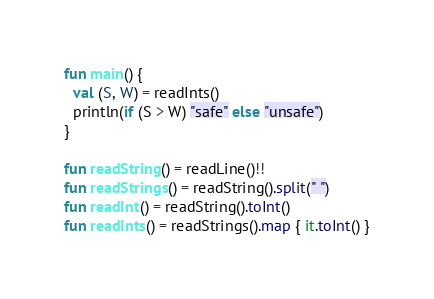<code> <loc_0><loc_0><loc_500><loc_500><_Kotlin_>fun main() {
  val (S, W) = readInts()
  println(if (S > W) "safe" else "unsafe")
}

fun readString() = readLine()!!
fun readStrings() = readString().split(" ")
fun readInt() = readString().toInt()
fun readInts() = readStrings().map { it.toInt() }
</code> 